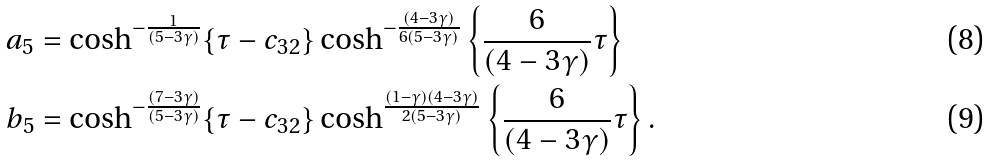<formula> <loc_0><loc_0><loc_500><loc_500>a _ { 5 } & = \cosh ^ { - \frac { 1 } { ( 5 - 3 \gamma ) } } \{ \tau - c _ { 3 2 } \} \cosh ^ { - \frac { ( 4 - 3 \gamma ) } { 6 ( 5 - 3 \gamma ) } } \left \{ \frac { 6 } { ( 4 - 3 \gamma ) } \tau \right \} \\ b _ { 5 } & = \cosh ^ { - \frac { ( 7 - 3 \gamma ) } { ( 5 - 3 \gamma ) } } \{ \tau - c _ { 3 2 } \} \cosh ^ { \frac { ( 1 - \gamma ) ( 4 - 3 \gamma ) } { 2 ( 5 - 3 \gamma ) } } \left \{ \frac { 6 } { ( 4 - 3 \gamma ) } \tau \right \} .</formula> 